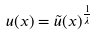<formula> <loc_0><loc_0><loc_500><loc_500>u ( x ) = \tilde { u } ( x ) ^ { \frac { 1 } { \lambda } }</formula> 